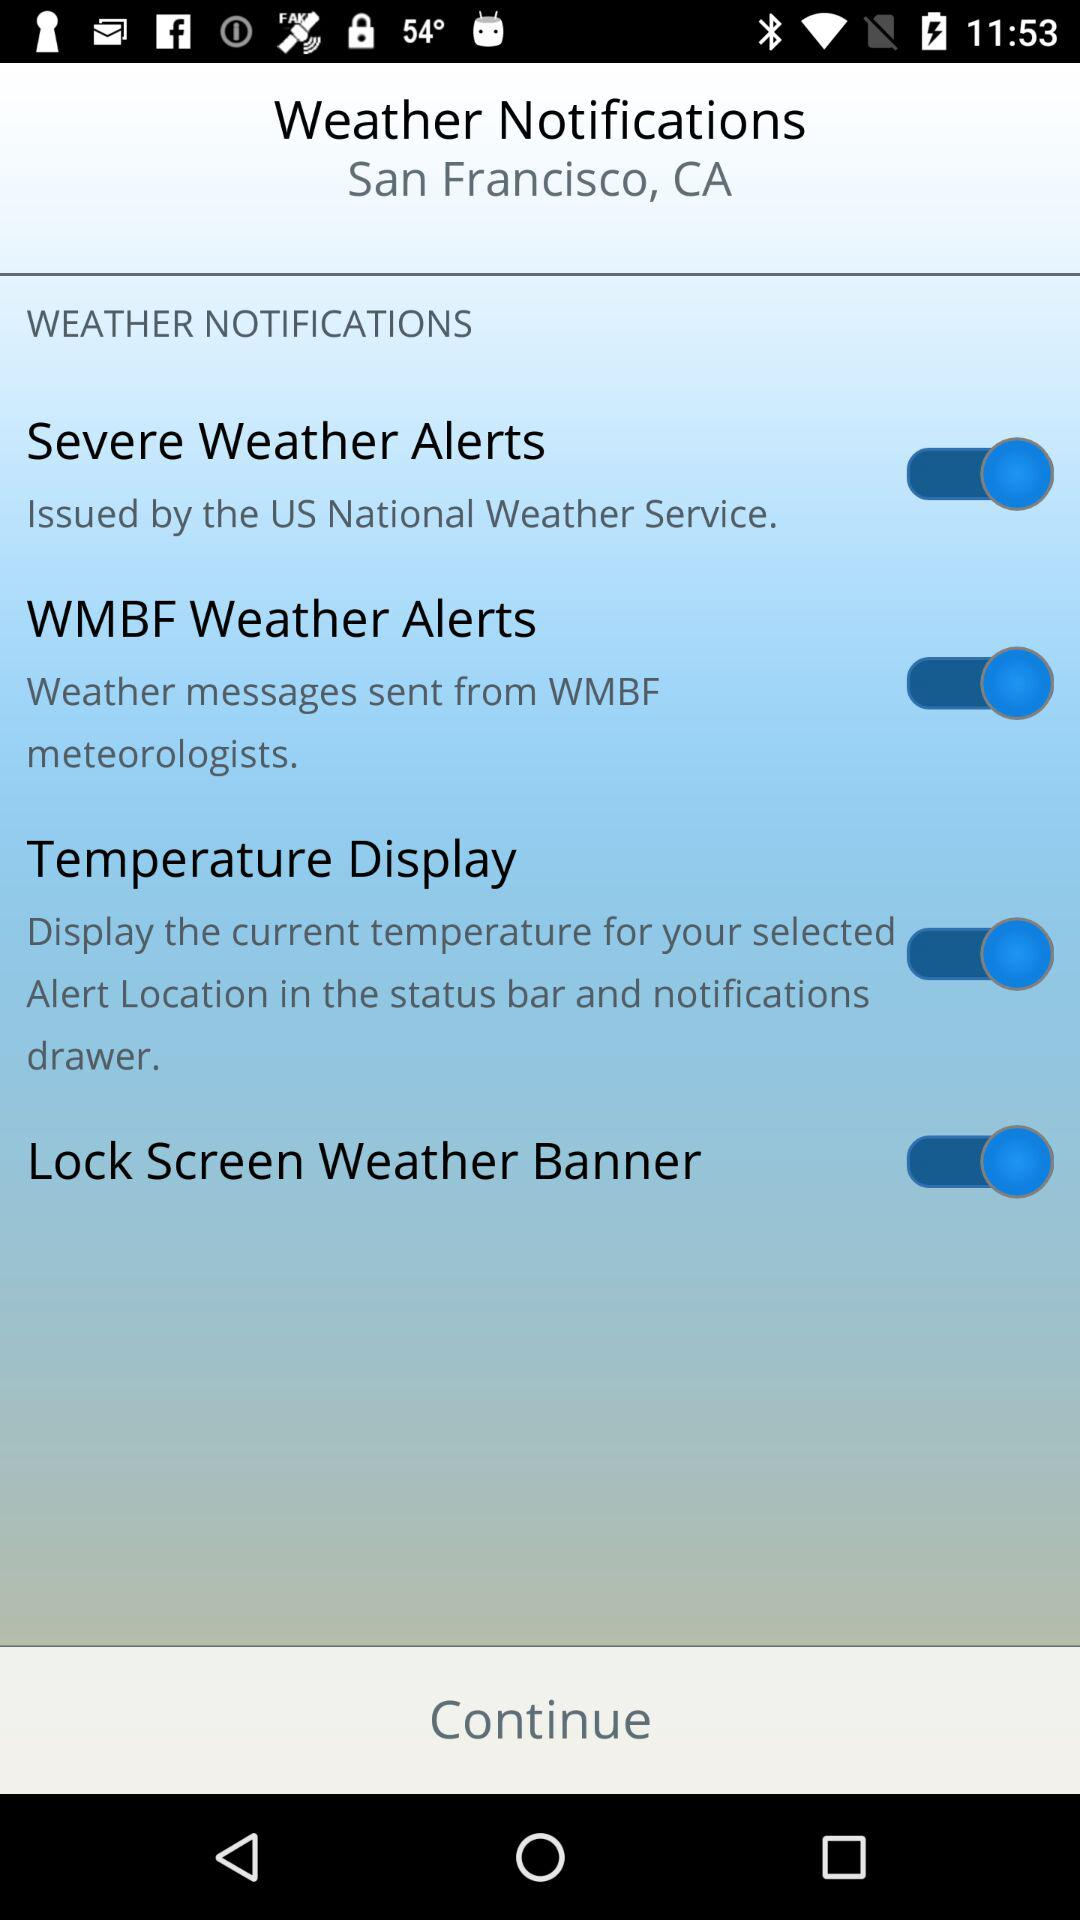How many more items are there with the label 'Temperature Display' than the label 'Severe Weather Alerts'?
Answer the question using a single word or phrase. 1 